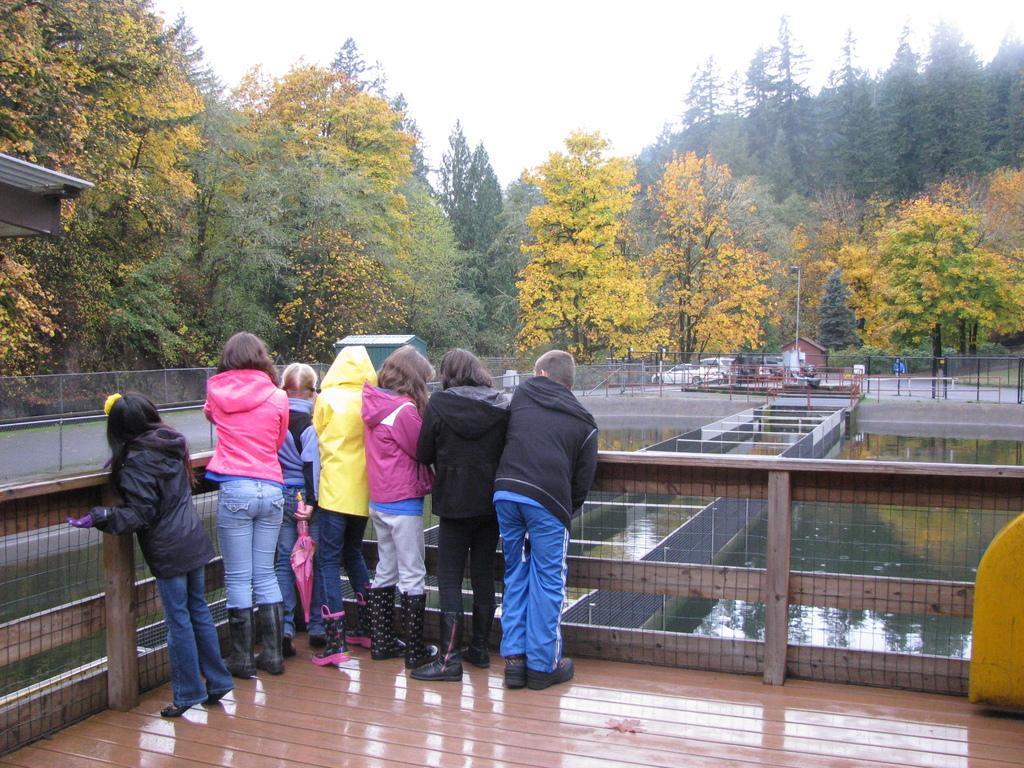Can you describe this image briefly? In this picture I can see a group of children in the middle, there is water on the right side, in the background I can see few vehicles and trees, at the top there is the sky. 